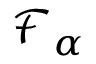Convert formula to latex. <formula><loc_0><loc_0><loc_500><loc_500>{ \mathcal { F } } _ { \alpha }</formula> 